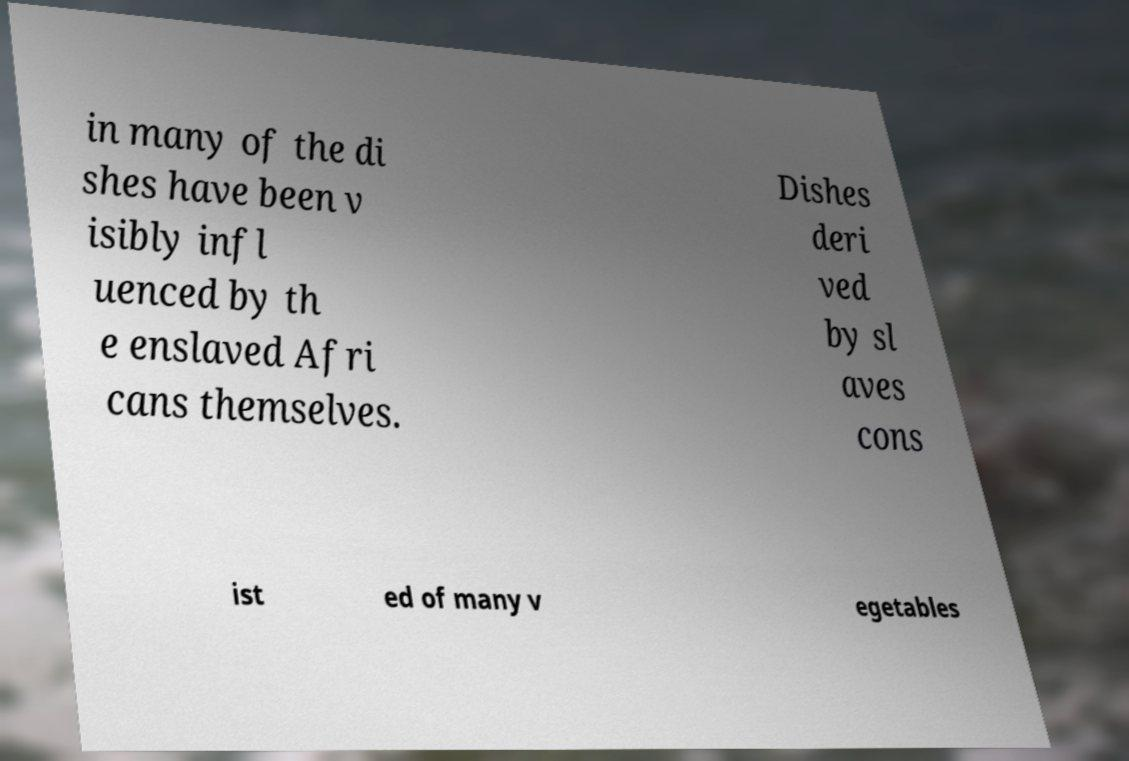Could you extract and type out the text from this image? in many of the di shes have been v isibly infl uenced by th e enslaved Afri cans themselves. Dishes deri ved by sl aves cons ist ed of many v egetables 